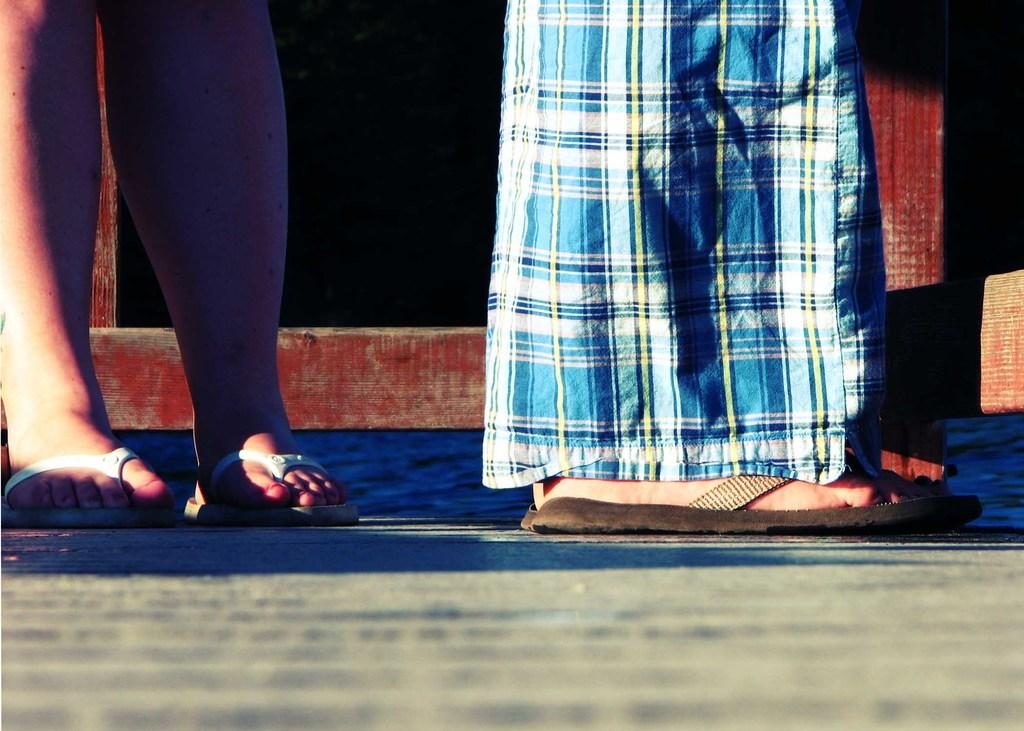How many people are present in the image? There are two people in the image, as indicated by the presence of their legs. What can be seen behind the people in the image? There is a wooden structure behind the people. How many frogs are sitting on the wooden structure in the image? There are no frogs present in the image; only the legs of two people and a wooden structure are visible. 